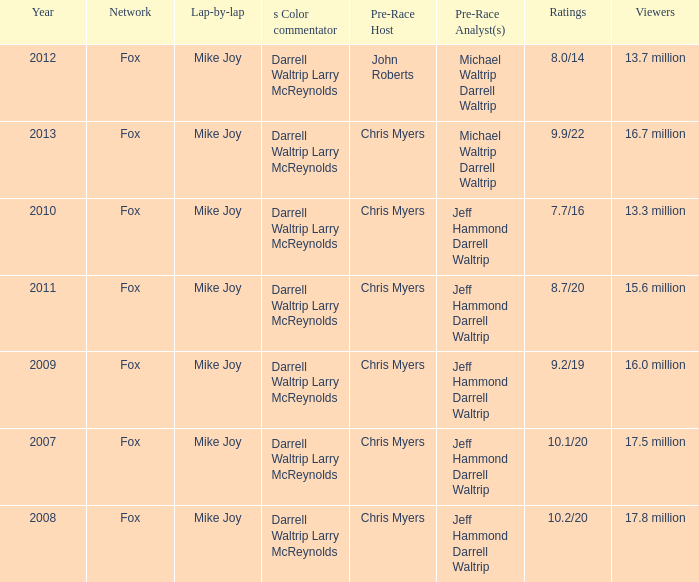Parse the table in full. {'header': ['Year', 'Network', 'Lap-by-lap', 's Color commentator', 'Pre-Race Host', 'Pre-Race Analyst(s)', 'Ratings', 'Viewers'], 'rows': [['2012', 'Fox', 'Mike Joy', 'Darrell Waltrip Larry McReynolds', 'John Roberts', 'Michael Waltrip Darrell Waltrip', '8.0/14', '13.7 million'], ['2013', 'Fox', 'Mike Joy', 'Darrell Waltrip Larry McReynolds', 'Chris Myers', 'Michael Waltrip Darrell Waltrip', '9.9/22', '16.7 million'], ['2010', 'Fox', 'Mike Joy', 'Darrell Waltrip Larry McReynolds', 'Chris Myers', 'Jeff Hammond Darrell Waltrip', '7.7/16', '13.3 million'], ['2011', 'Fox', 'Mike Joy', 'Darrell Waltrip Larry McReynolds', 'Chris Myers', 'Jeff Hammond Darrell Waltrip', '8.7/20', '15.6 million'], ['2009', 'Fox', 'Mike Joy', 'Darrell Waltrip Larry McReynolds', 'Chris Myers', 'Jeff Hammond Darrell Waltrip', '9.2/19', '16.0 million'], ['2007', 'Fox', 'Mike Joy', 'Darrell Waltrip Larry McReynolds', 'Chris Myers', 'Jeff Hammond Darrell Waltrip', '10.1/20', '17.5 million'], ['2008', 'Fox', 'Mike Joy', 'Darrell Waltrip Larry McReynolds', 'Chris Myers', 'Jeff Hammond Darrell Waltrip', '10.2/20', '17.8 million']]} Which Network has 16.0 million Viewers? Fox. 